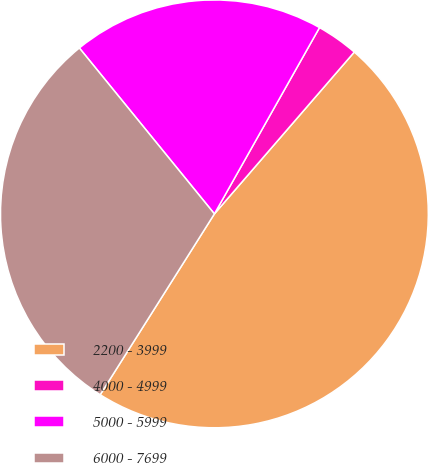Convert chart to OTSL. <chart><loc_0><loc_0><loc_500><loc_500><pie_chart><fcel>2200 - 3999<fcel>4000 - 4999<fcel>5000 - 5999<fcel>6000 - 7699<nl><fcel>47.62%<fcel>3.17%<fcel>19.05%<fcel>30.16%<nl></chart> 